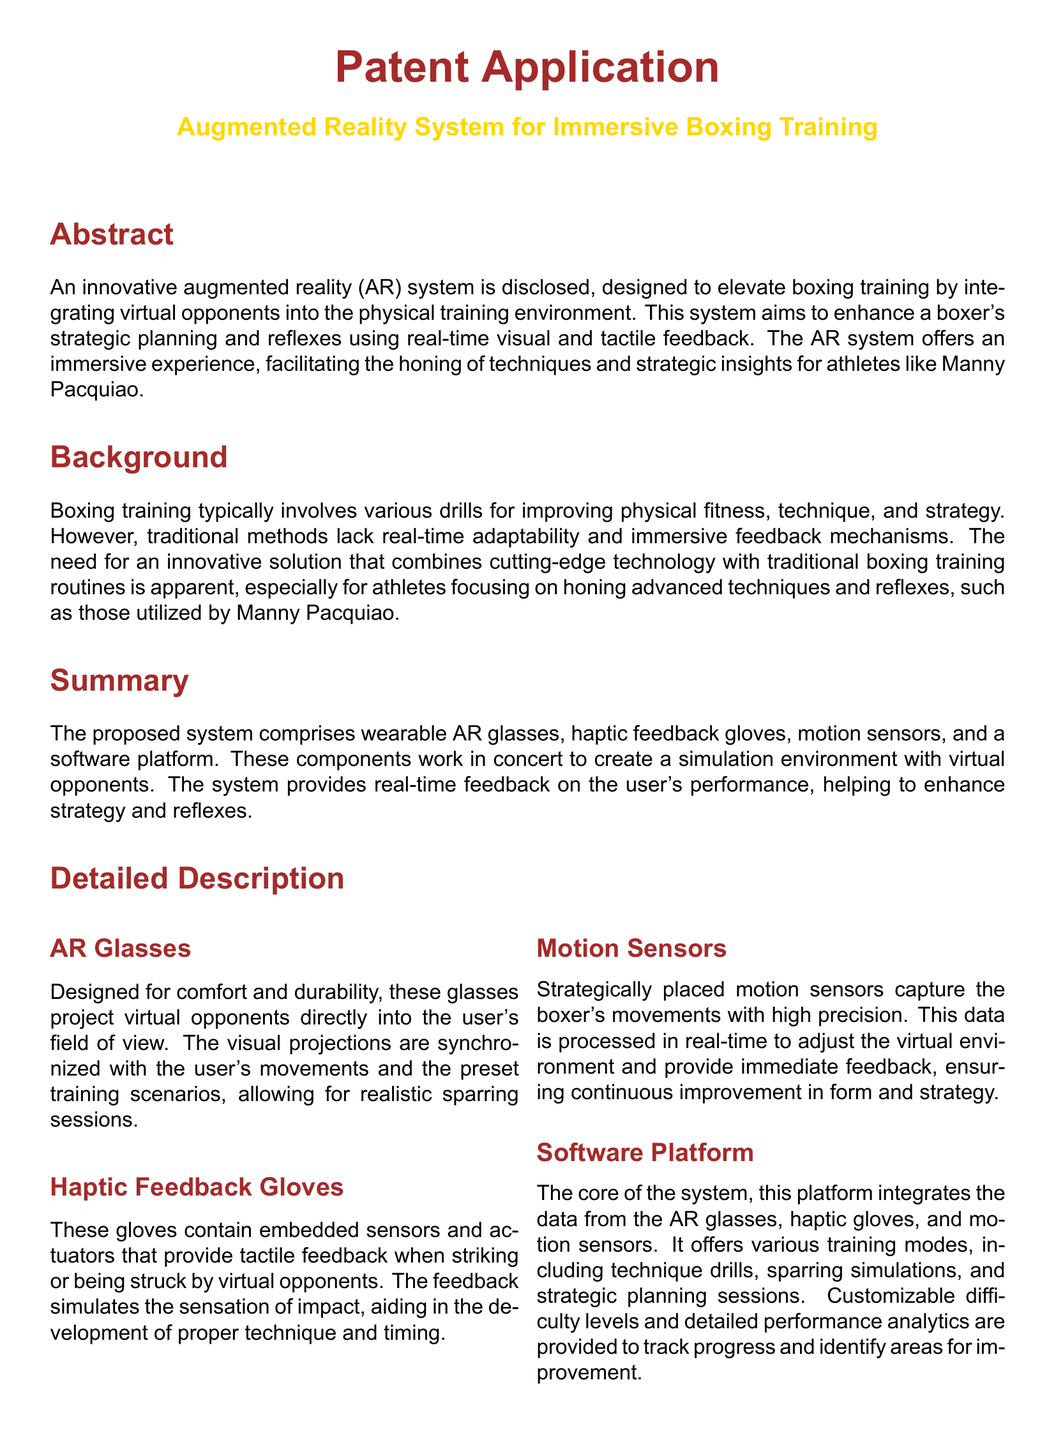What is the title of the patent application? The title of the patent application is listed prominently in the document and is "Augmented Reality System for Immersive Boxing Training".
Answer: Augmented Reality System for Immersive Boxing Training What does the AR system simulate? The abstract mentions that the AR system simulates virtual opponents, enhancing the training environment for boxers.
Answer: Virtual opponents What are the components of the proposed system? The summary outlines the system's components as wearable AR glasses, haptic feedback gloves, motion sensors, and a software platform.
Answer: AR glasses, haptic feedback gloves, motion sensors, software platform What type of feedback do the haptic gloves provide? The detailed description states that the haptic feedback gloves provide tactile feedback during training sessions.
Answer: Tactile feedback What is the primary function of the software platform? The detailed description mentions that the software platform integrates data and offers various training modes tailored to boxers' needs.
Answer: Training modes How many claims are made in the document? The claims section clearly enumerates the components of the system as four distinct claims.
Answer: Four What advantage does the system offer regarding strategy development? The advantages section highlights that the system enhances strategy development through realistic virtual sparring.
Answer: Realistic virtual sparring In what environments can the system be applied? The potential applications list various environments including professional training camps, amateur facilities, military programs, and sports science research.
Answer: Professional boxer training camps, amateur boxing training facilities, military and law enforcement training programs, sports science research What type of feedback is provided to improve reflexes? The advantages section states that real-time visual and tactile feedback helps improve reflexes and timing.
Answer: Real-time visual and tactile feedback 